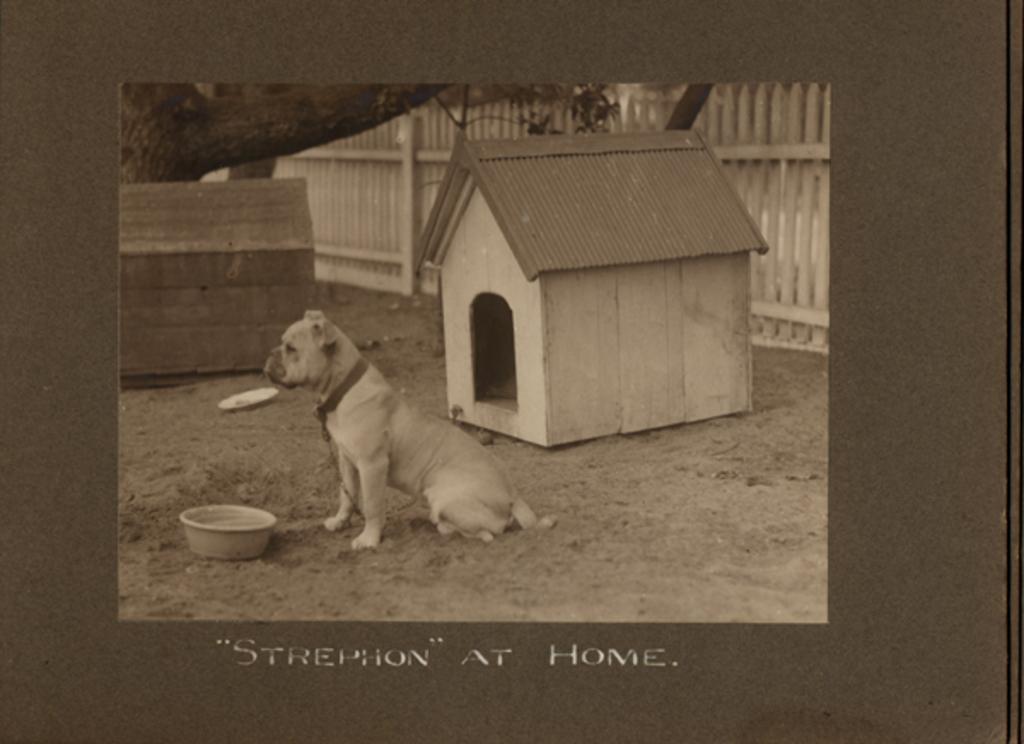Please provide a concise description of this image. In the image we can see a dog, in front of the dog there is a bowl. Here we can see a dog house, wooden fence, wooden box and tree branch. Here we can see the text. 